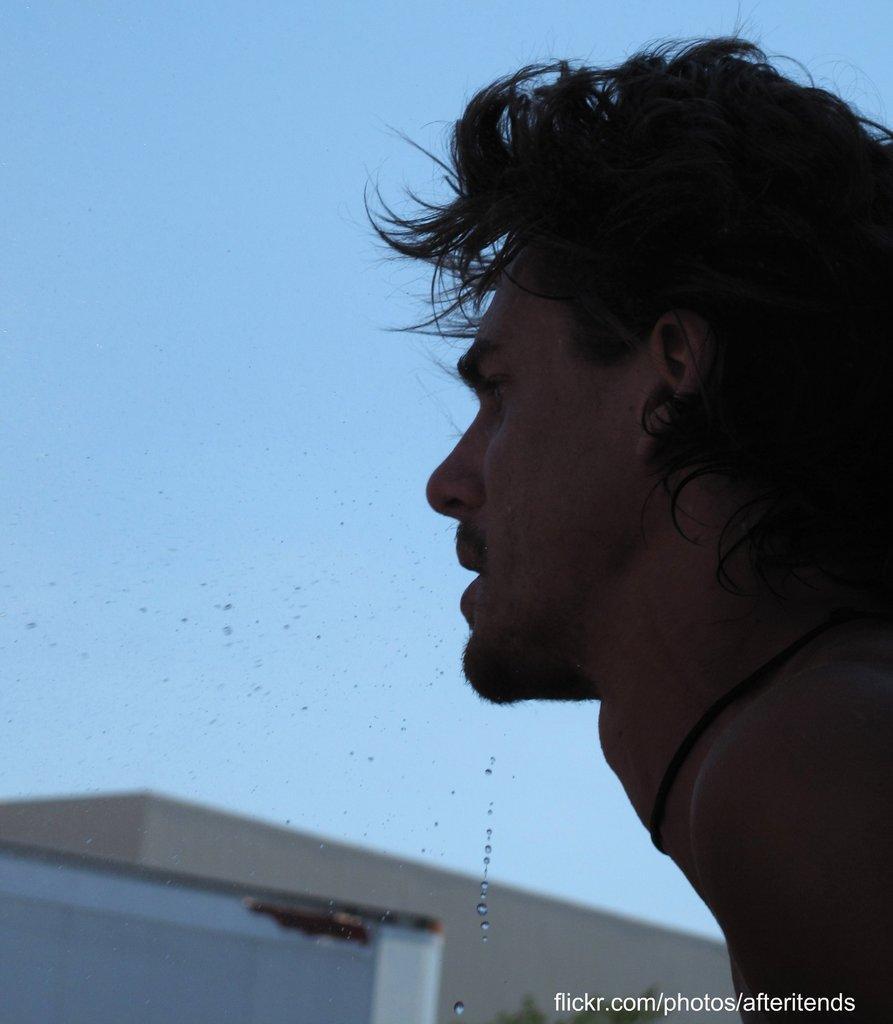Please provide a concise description of this image. In this image we can see a man and here we can see the water droplets. The background of the image is blurred, where we can see a house and the blue color sky. Here we can see the watermark on the bottom right side of the image. 